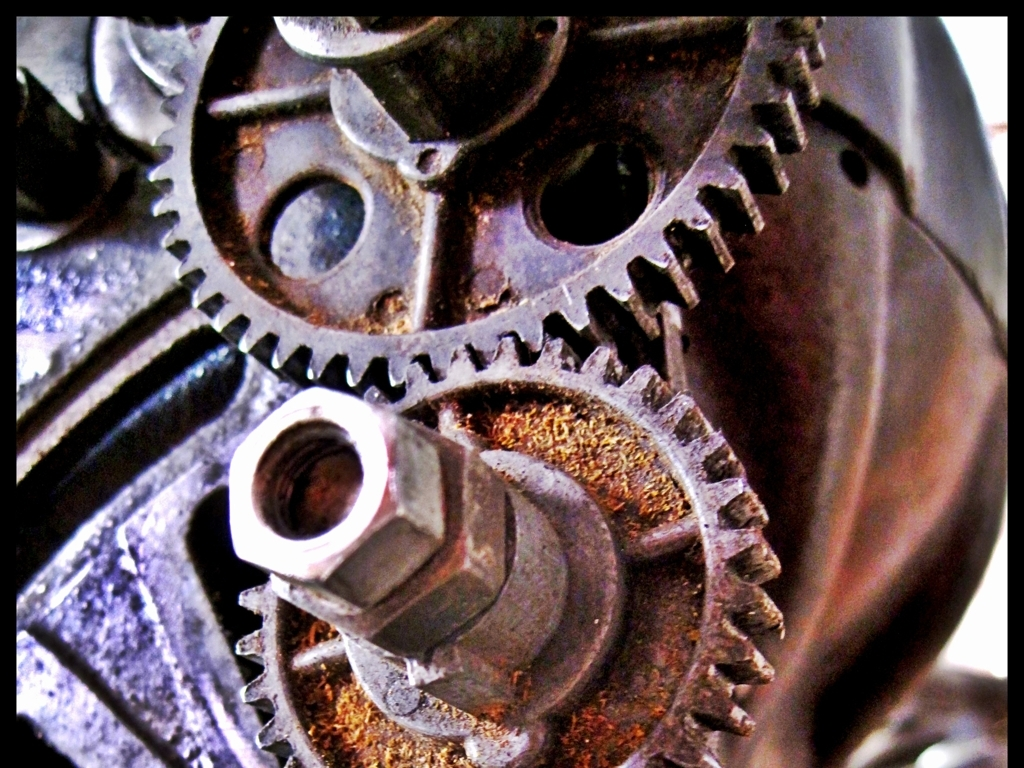What type of machine do you think these gears belong to? The gears in the image appear to be industrial, suggesting they might belong to a machine used in manufacturing or mechanical processing, possibly related to engines or heavy machinery due to their robust and metallic nature. 